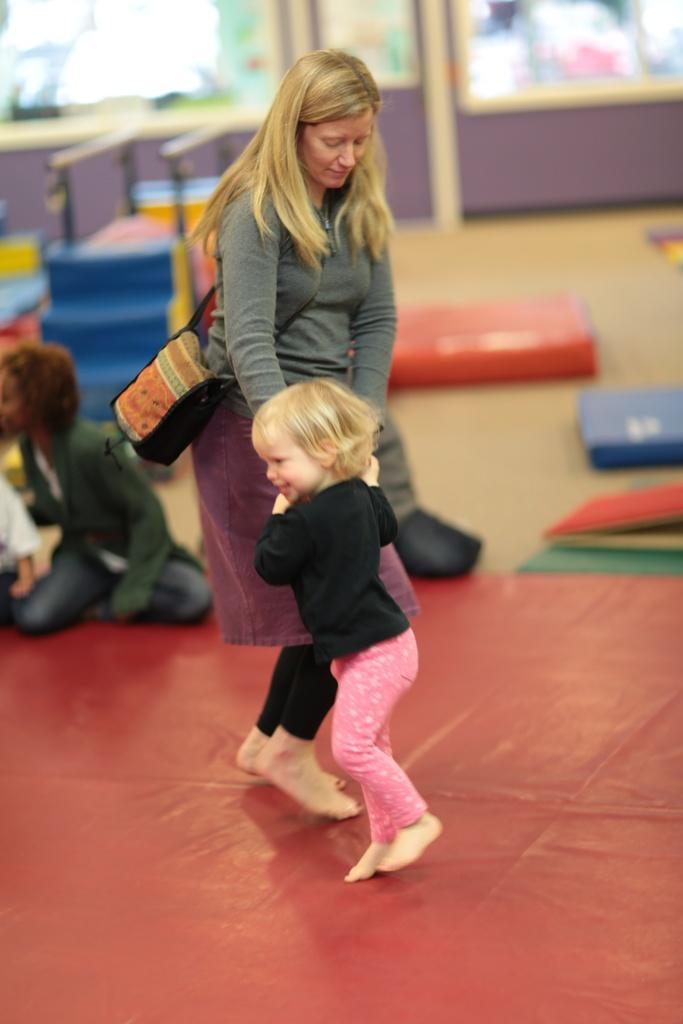Describe this image in one or two sentences. In this image we can see a lady and a girl. At the bottom of the image there is a red color surface. In the background of the image there are people sitting on the floor. There are mats. There is a wall. 